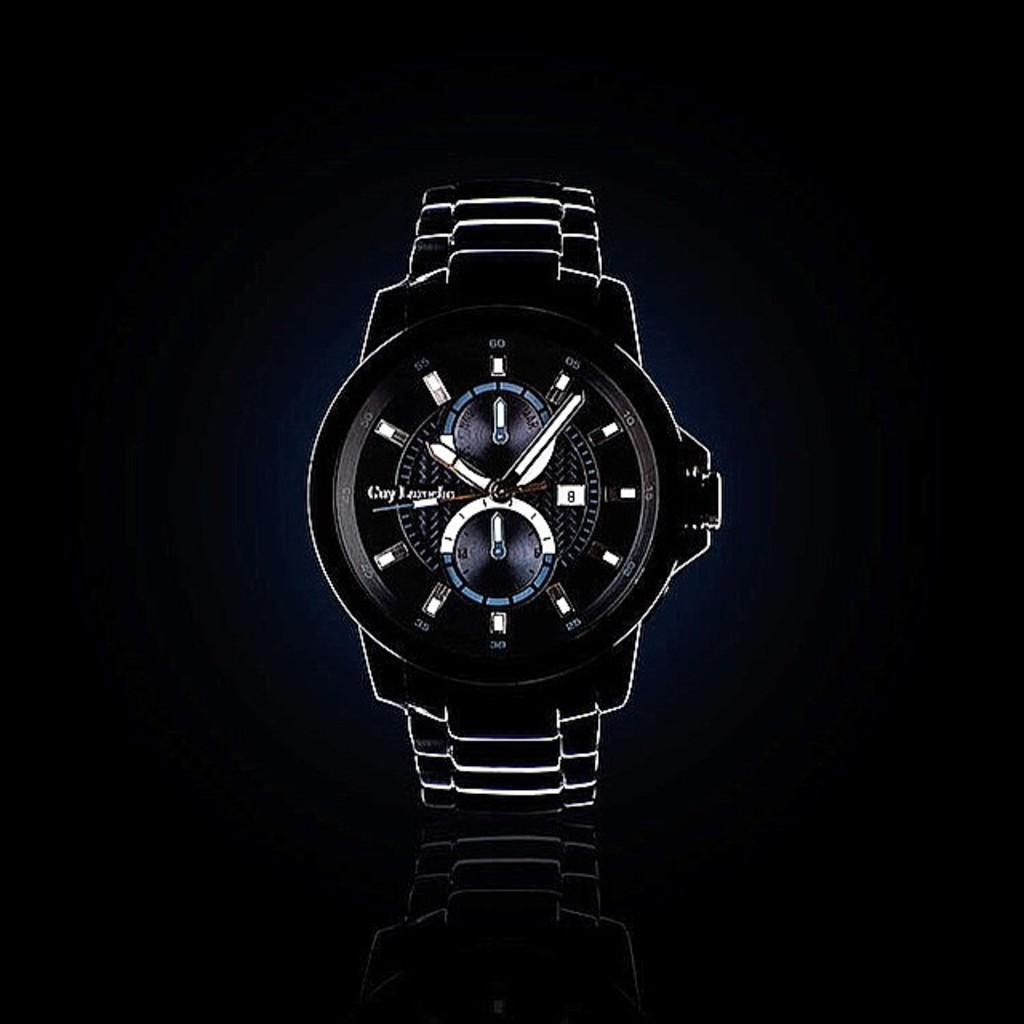What object is the main focus of the image? There is a black watch in the image. What color is the watch? The watch is black. What can be seen in the background of the image? The background of the image is black. What type of pancake is being served in the image? There is no pancake present in the image; it features a black watch with a black background. What route is the prisoner taking in the image? There is no prisoner or route depicted in the image; it only shows a black watch against a black background. 